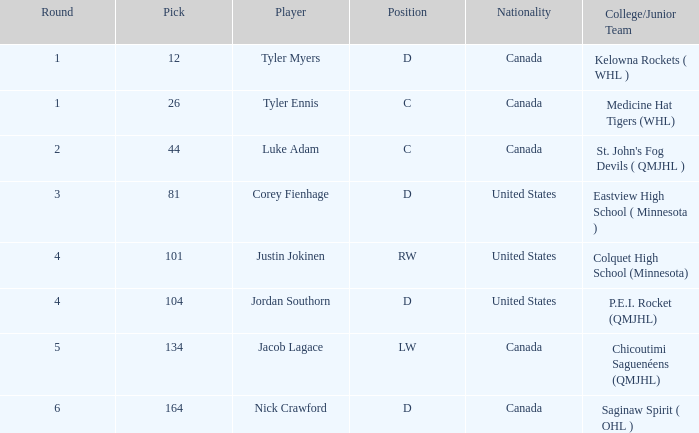What is the collegiate/minor team of player tyler myers, who has a choice less than 44? Kelowna Rockets ( WHL ). 